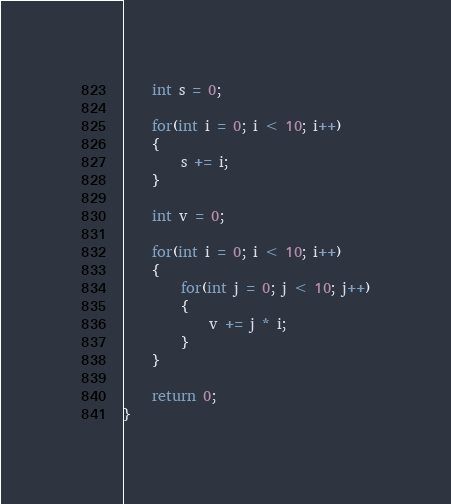Convert code to text. <code><loc_0><loc_0><loc_500><loc_500><_C_>    int s = 0;
    
    for(int i = 0; i < 10; i++)
    {
        s += i;
    }
    
    int v = 0;
    
    for(int i = 0; i < 10; i++)
    {
        for(int j = 0; j < 10; j++)
        {
            v += j * i;
        }
    }
    
    return 0;
}</code> 